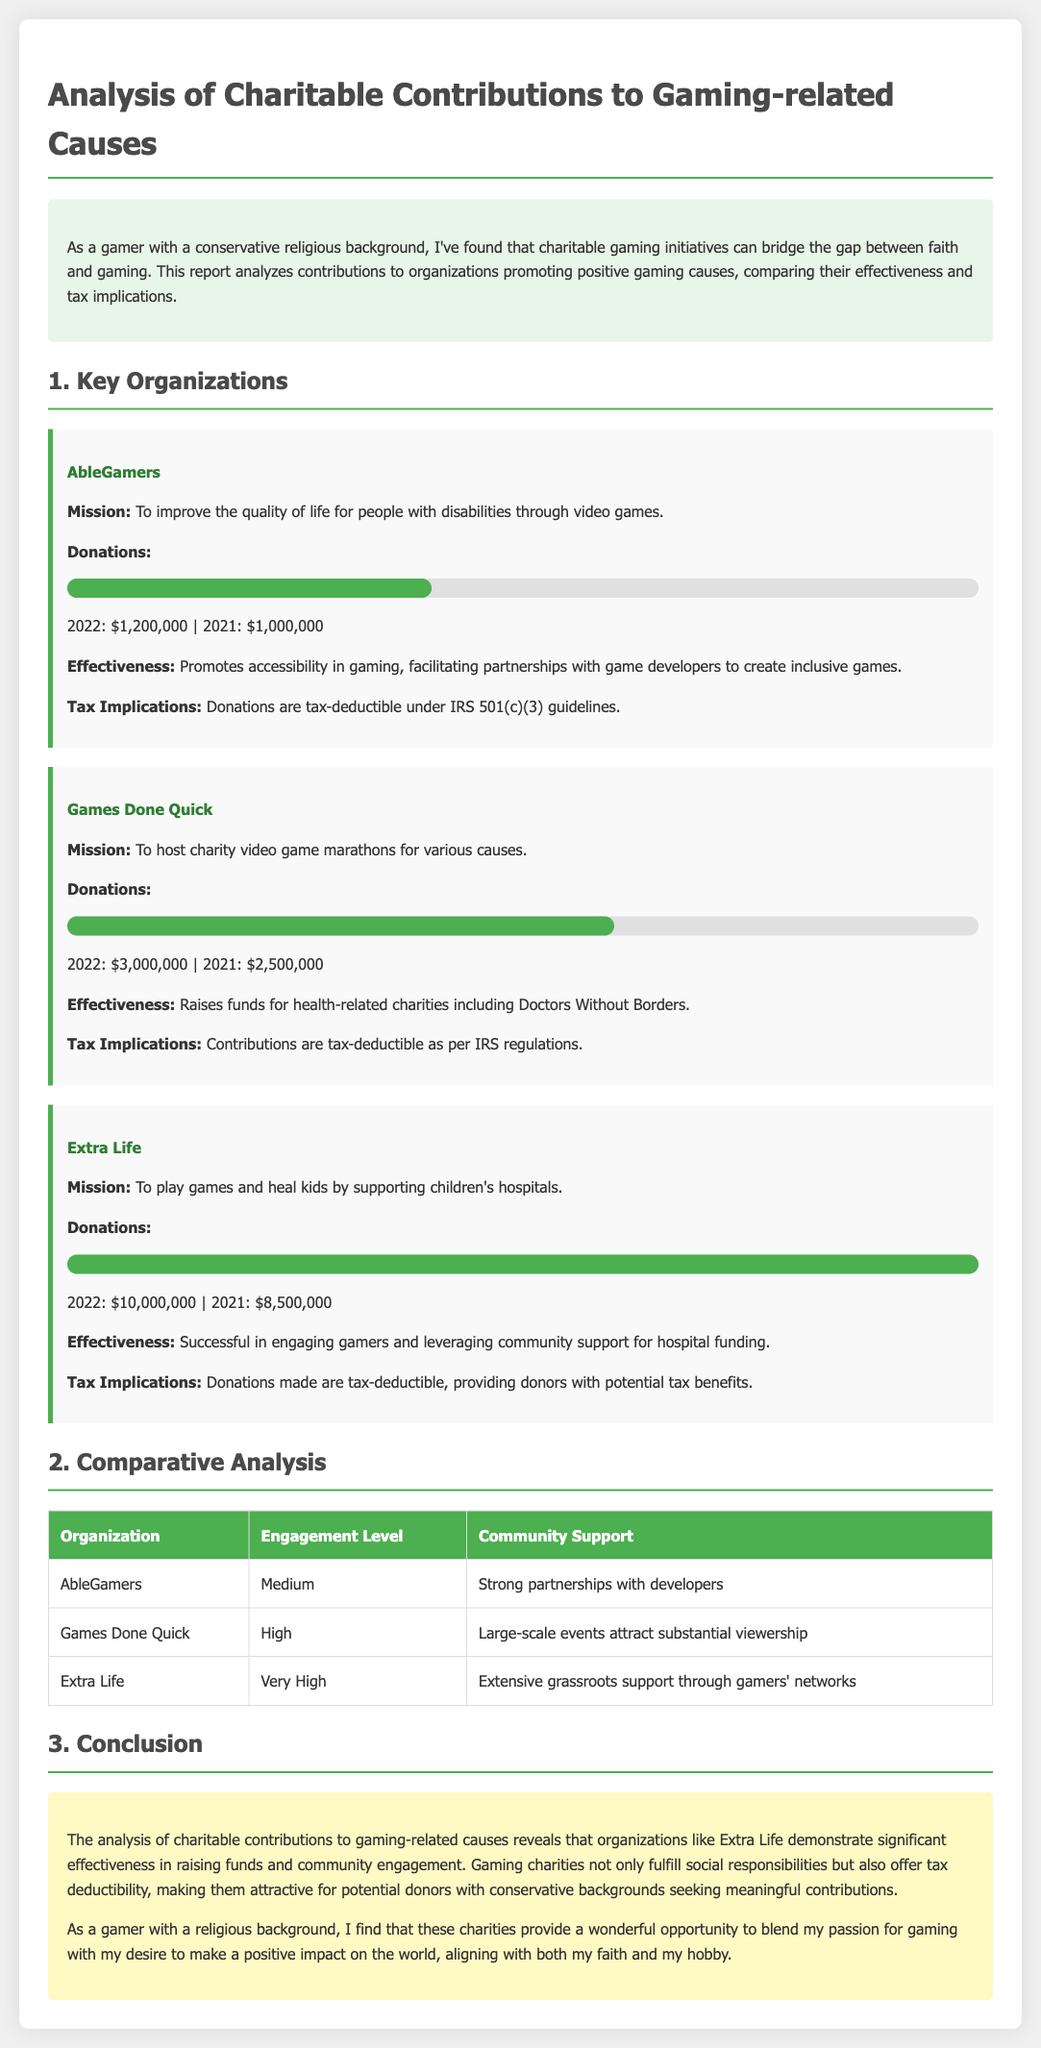What is the main mission of AbleGamers? The main mission of AbleGamers is to improve the quality of life for people with disabilities through video games.
Answer: To improve the quality of life for people with disabilities through video games How much did Extra Life raise in 2022? The document states that Extra Life raised $10,000,000 in donations in 2022.
Answer: $10,000,000 What was the percentage increase of donations for Games Done Quick from 2021 to 2022? The increase is calculated as follows: ($3,000,000 - $2,500,000) / $2,500,000 * 100% = 20%.
Answer: 20% Which organization received the highest level of community support? The document indicates that Extra Life has extensive grassroots support through gamers' networks, which is the highest level of community support.
Answer: Extra Life What are the tax implications for donations made to Games Done Quick? Donations made to Games Done Quick are tax-deductible as per IRS regulations.
Answer: Tax-deductible Which organization is focused on promoting accessibility in gaming? The document identifies AbleGamers as the organization focused on promoting accessibility in gaming.
Answer: AbleGamers What engagement level does Games Done Quick have? The engagement level for Games Done Quick is noted as high in the comparative analysis.
Answer: High What year had the lowest donations for AbleGamers? The report shows that AbleGamers had the lowest donations in 2021, with $1,000,000.
Answer: 2021 